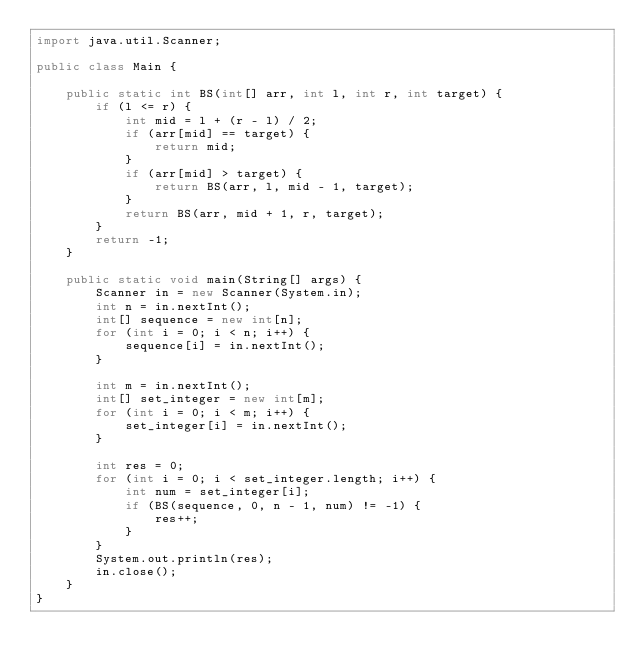<code> <loc_0><loc_0><loc_500><loc_500><_Java_>import java.util.Scanner;

public class Main {
	
	public static int BS(int[] arr, int l, int r, int target) {
		if (l <= r) {
			int mid = l + (r - l) / 2;
			if (arr[mid] == target) {
				return mid;
			}
			if (arr[mid] > target) {
				return BS(arr, l, mid - 1, target);
			}
			return BS(arr, mid + 1, r, target);
		}
		return -1;
	}
	
	public static void main(String[] args) {
		Scanner in = new Scanner(System.in);
		int n = in.nextInt();
		int[] sequence = new int[n];
		for (int i = 0; i < n; i++) {
			sequence[i] = in.nextInt();
		}
		
		int m = in.nextInt();
		int[] set_integer = new int[m];
		for (int i = 0; i < m; i++) {
			set_integer[i] = in.nextInt();
		}
		
		int res = 0;
		for (int i = 0; i < set_integer.length; i++) {
			int num = set_integer[i];
			if (BS(sequence, 0, n - 1, num) != -1) {
				res++;
			}
		}
		System.out.println(res);
		in.close();
	}
}
</code> 